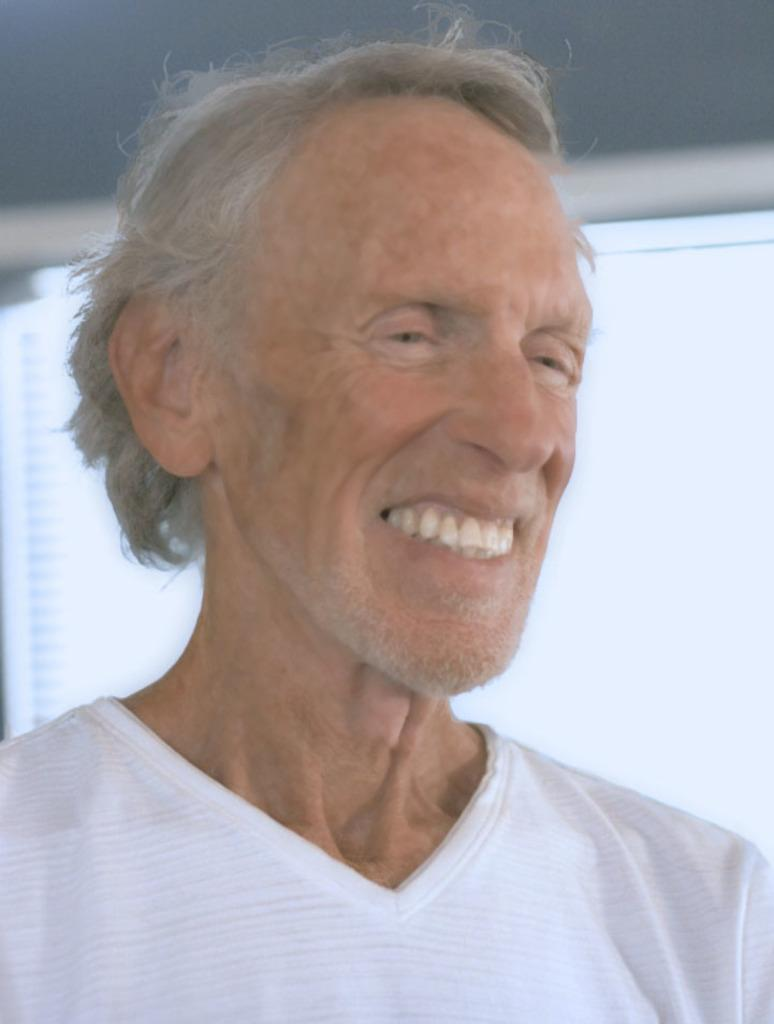What can be observed about the person in the image? The person in the image is smiling. Can you describe the person's expression in the image? The person has a smiling expression in the image. What is present in the background of the image? There is an object in the background of the image. What type of prose can be heard being recited by the person in the image? There is no indication in the image that the person is reciting any prose, so it cannot be determined from the picture. 